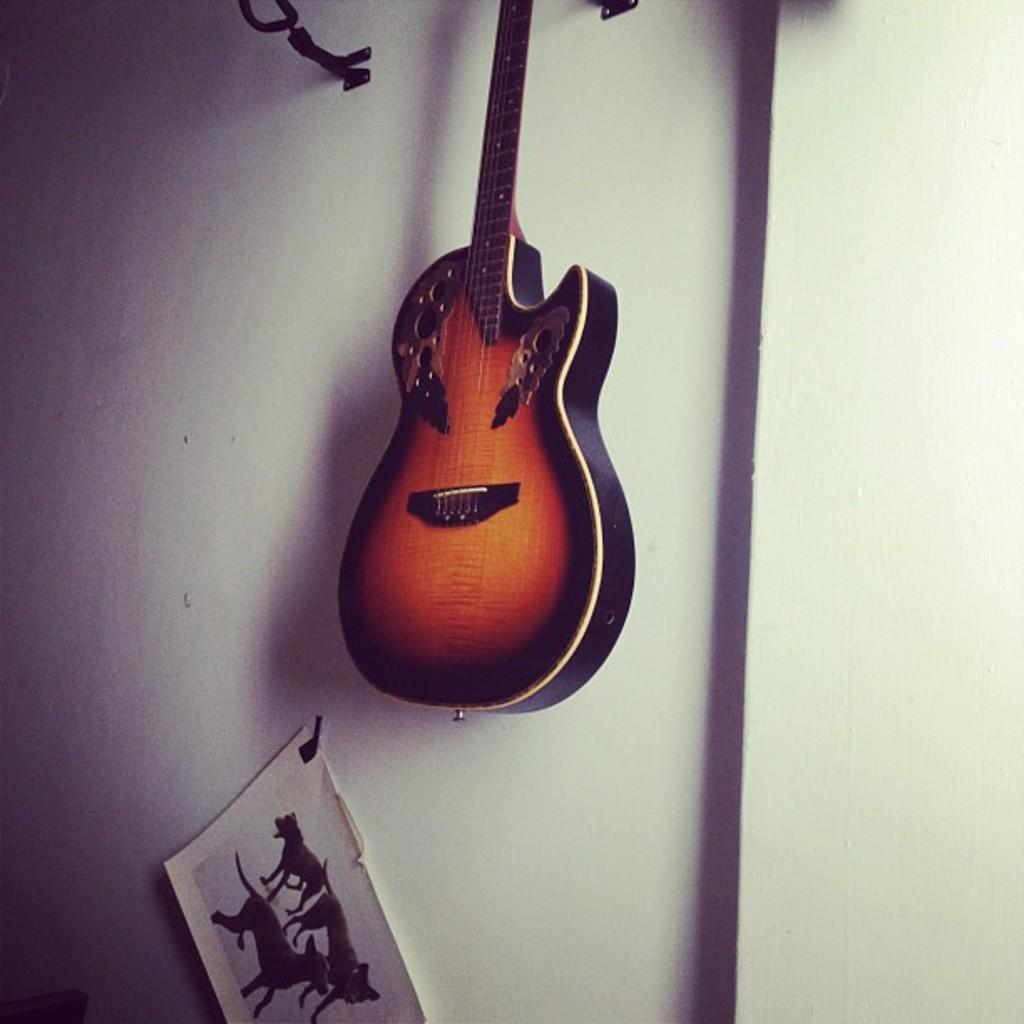What is the color of the wall in the image? The wall in the image is white. What can be seen hanging on the wall? There is a black and yellow color music instrument hanging on the wall. Is there any other decoration on the wall? Yes, there is a picture pasted on the wall. What type of animal is sitting on the cactus in the image? There is no animal or cactus present in the image; it only features a white wall, a black and yellow music instrument, and a picture. 